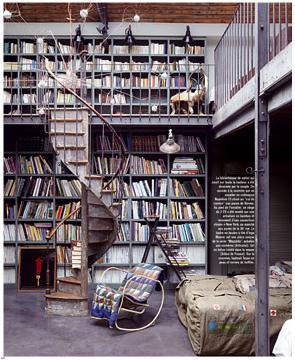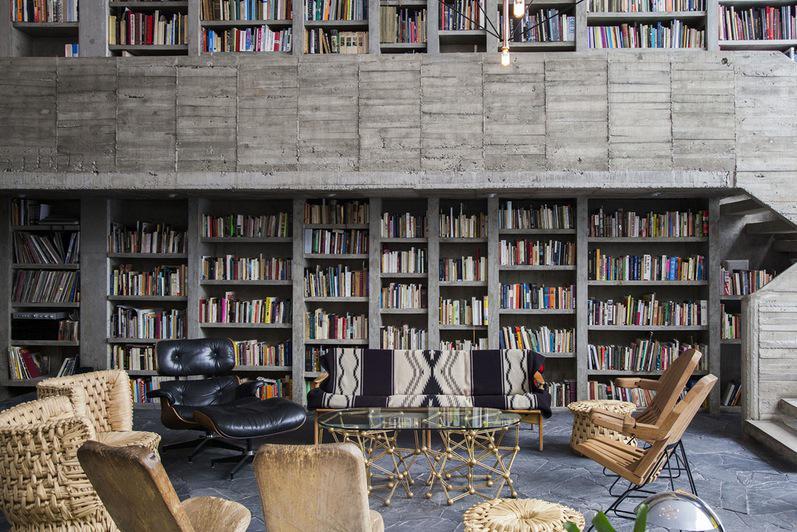The first image is the image on the left, the second image is the image on the right. For the images displayed, is the sentence "There is one ladder leaning against a bookcase." factually correct? Answer yes or no. No. The first image is the image on the left, the second image is the image on the right. Examine the images to the left and right. Is the description "The reading are in the image on the right includes seating near a window." accurate? Answer yes or no. No. 